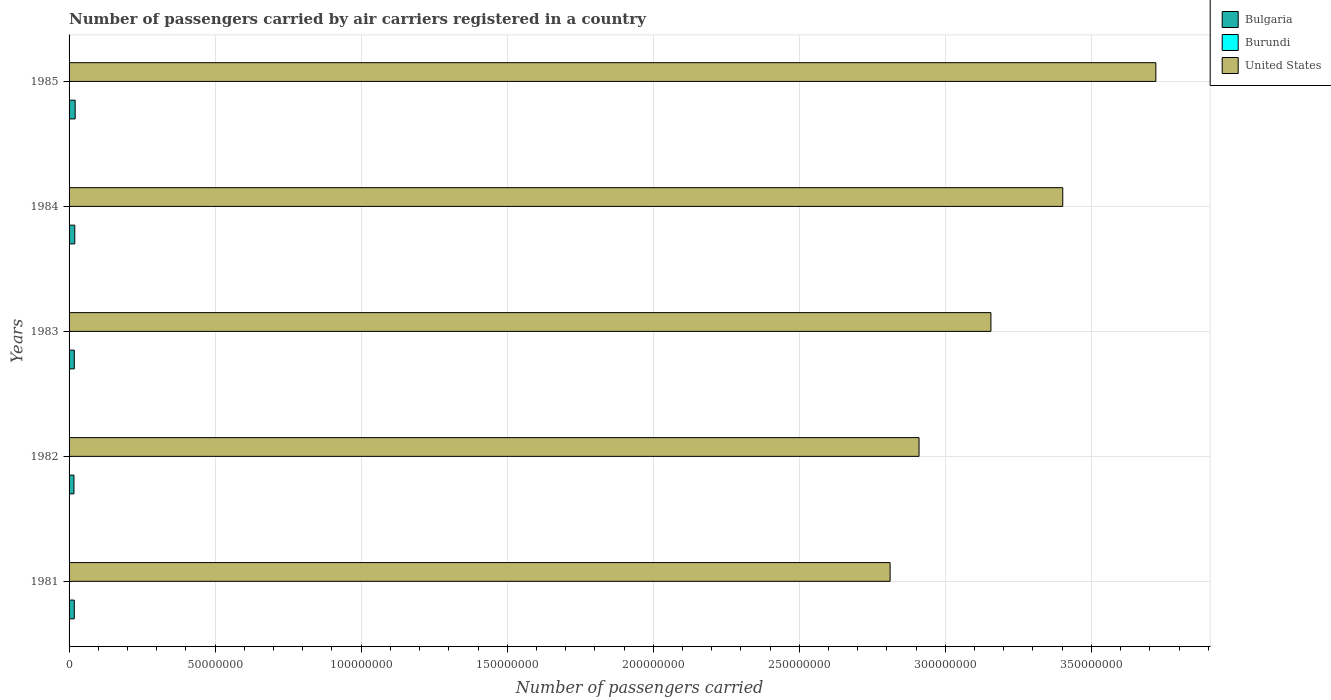How many different coloured bars are there?
Provide a short and direct response. 3. Are the number of bars on each tick of the Y-axis equal?
Provide a short and direct response. Yes. How many bars are there on the 1st tick from the top?
Your response must be concise. 3. What is the number of passengers carried by air carriers in United States in 1982?
Your response must be concise. 2.91e+08. Across all years, what is the maximum number of passengers carried by air carriers in United States?
Offer a very short reply. 3.72e+08. Across all years, what is the minimum number of passengers carried by air carriers in United States?
Keep it short and to the point. 2.81e+08. What is the total number of passengers carried by air carriers in Bulgaria in the graph?
Your response must be concise. 9.29e+06. What is the difference between the number of passengers carried by air carriers in Bulgaria in 1981 and that in 1984?
Keep it short and to the point. -1.63e+05. What is the difference between the number of passengers carried by air carriers in Burundi in 1985 and the number of passengers carried by air carriers in United States in 1983?
Provide a short and direct response. -3.16e+08. What is the average number of passengers carried by air carriers in Bulgaria per year?
Provide a succinct answer. 1.86e+06. In the year 1982, what is the difference between the number of passengers carried by air carriers in Burundi and number of passengers carried by air carriers in Bulgaria?
Keep it short and to the point. -1.67e+06. In how many years, is the number of passengers carried by air carriers in Burundi greater than 180000000 ?
Your response must be concise. 0. What is the ratio of the number of passengers carried by air carriers in Burundi in 1984 to that in 1985?
Keep it short and to the point. 1.02. Is the number of passengers carried by air carriers in Bulgaria in 1982 less than that in 1985?
Provide a succinct answer. Yes. What is the difference between the highest and the lowest number of passengers carried by air carriers in Burundi?
Make the answer very short. 3800. What does the 2nd bar from the top in 1983 represents?
Make the answer very short. Burundi. Are all the bars in the graph horizontal?
Give a very brief answer. Yes. Are the values on the major ticks of X-axis written in scientific E-notation?
Offer a terse response. No. Does the graph contain any zero values?
Make the answer very short. No. Does the graph contain grids?
Offer a terse response. Yes. What is the title of the graph?
Offer a terse response. Number of passengers carried by air carriers registered in a country. What is the label or title of the X-axis?
Offer a very short reply. Number of passengers carried. What is the Number of passengers carried of Bulgaria in 1981?
Your answer should be compact. 1.79e+06. What is the Number of passengers carried of United States in 1981?
Your response must be concise. 2.81e+08. What is the Number of passengers carried in Bulgaria in 1982?
Provide a succinct answer. 1.68e+06. What is the Number of passengers carried in Burundi in 1982?
Offer a terse response. 5500. What is the Number of passengers carried of United States in 1982?
Offer a very short reply. 2.91e+08. What is the Number of passengers carried of Bulgaria in 1983?
Your answer should be very brief. 1.79e+06. What is the Number of passengers carried in Burundi in 1983?
Ensure brevity in your answer.  6000. What is the Number of passengers carried of United States in 1983?
Offer a very short reply. 3.16e+08. What is the Number of passengers carried in Bulgaria in 1984?
Your answer should be very brief. 1.95e+06. What is the Number of passengers carried of Burundi in 1984?
Offer a very short reply. 8800. What is the Number of passengers carried of United States in 1984?
Your answer should be very brief. 3.40e+08. What is the Number of passengers carried of Bulgaria in 1985?
Give a very brief answer. 2.09e+06. What is the Number of passengers carried of Burundi in 1985?
Keep it short and to the point. 8600. What is the Number of passengers carried of United States in 1985?
Your response must be concise. 3.72e+08. Across all years, what is the maximum Number of passengers carried in Bulgaria?
Offer a very short reply. 2.09e+06. Across all years, what is the maximum Number of passengers carried of Burundi?
Your response must be concise. 8800. Across all years, what is the maximum Number of passengers carried in United States?
Offer a very short reply. 3.72e+08. Across all years, what is the minimum Number of passengers carried of Bulgaria?
Offer a very short reply. 1.68e+06. Across all years, what is the minimum Number of passengers carried of United States?
Your response must be concise. 2.81e+08. What is the total Number of passengers carried of Bulgaria in the graph?
Your response must be concise. 9.29e+06. What is the total Number of passengers carried of Burundi in the graph?
Keep it short and to the point. 3.39e+04. What is the total Number of passengers carried in United States in the graph?
Ensure brevity in your answer.  1.60e+09. What is the difference between the Number of passengers carried of Bulgaria in 1981 and that in 1982?
Provide a short and direct response. 1.12e+05. What is the difference between the Number of passengers carried in Burundi in 1981 and that in 1982?
Provide a short and direct response. -500. What is the difference between the Number of passengers carried in United States in 1981 and that in 1982?
Give a very brief answer. -9.91e+06. What is the difference between the Number of passengers carried of Bulgaria in 1981 and that in 1983?
Make the answer very short. -3000. What is the difference between the Number of passengers carried of Burundi in 1981 and that in 1983?
Offer a very short reply. -1000. What is the difference between the Number of passengers carried of United States in 1981 and that in 1983?
Offer a terse response. -3.45e+07. What is the difference between the Number of passengers carried in Bulgaria in 1981 and that in 1984?
Provide a short and direct response. -1.63e+05. What is the difference between the Number of passengers carried of Burundi in 1981 and that in 1984?
Provide a succinct answer. -3800. What is the difference between the Number of passengers carried in United States in 1981 and that in 1984?
Offer a terse response. -5.91e+07. What is the difference between the Number of passengers carried of Bulgaria in 1981 and that in 1985?
Provide a succinct answer. -3.03e+05. What is the difference between the Number of passengers carried of Burundi in 1981 and that in 1985?
Provide a succinct answer. -3600. What is the difference between the Number of passengers carried of United States in 1981 and that in 1985?
Provide a succinct answer. -9.10e+07. What is the difference between the Number of passengers carried of Bulgaria in 1982 and that in 1983?
Your answer should be compact. -1.15e+05. What is the difference between the Number of passengers carried in Burundi in 1982 and that in 1983?
Make the answer very short. -500. What is the difference between the Number of passengers carried of United States in 1982 and that in 1983?
Your answer should be compact. -2.46e+07. What is the difference between the Number of passengers carried in Bulgaria in 1982 and that in 1984?
Offer a very short reply. -2.75e+05. What is the difference between the Number of passengers carried of Burundi in 1982 and that in 1984?
Offer a very short reply. -3300. What is the difference between the Number of passengers carried of United States in 1982 and that in 1984?
Your answer should be compact. -4.92e+07. What is the difference between the Number of passengers carried in Bulgaria in 1982 and that in 1985?
Make the answer very short. -4.15e+05. What is the difference between the Number of passengers carried of Burundi in 1982 and that in 1985?
Ensure brevity in your answer.  -3100. What is the difference between the Number of passengers carried of United States in 1982 and that in 1985?
Ensure brevity in your answer.  -8.11e+07. What is the difference between the Number of passengers carried in Burundi in 1983 and that in 1984?
Give a very brief answer. -2800. What is the difference between the Number of passengers carried in United States in 1983 and that in 1984?
Make the answer very short. -2.46e+07. What is the difference between the Number of passengers carried of Bulgaria in 1983 and that in 1985?
Make the answer very short. -3.00e+05. What is the difference between the Number of passengers carried of Burundi in 1983 and that in 1985?
Provide a short and direct response. -2600. What is the difference between the Number of passengers carried in United States in 1983 and that in 1985?
Keep it short and to the point. -5.65e+07. What is the difference between the Number of passengers carried of Bulgaria in 1984 and that in 1985?
Offer a terse response. -1.40e+05. What is the difference between the Number of passengers carried in United States in 1984 and that in 1985?
Your answer should be very brief. -3.19e+07. What is the difference between the Number of passengers carried of Bulgaria in 1981 and the Number of passengers carried of Burundi in 1982?
Offer a terse response. 1.78e+06. What is the difference between the Number of passengers carried of Bulgaria in 1981 and the Number of passengers carried of United States in 1982?
Keep it short and to the point. -2.89e+08. What is the difference between the Number of passengers carried of Burundi in 1981 and the Number of passengers carried of United States in 1982?
Keep it short and to the point. -2.91e+08. What is the difference between the Number of passengers carried of Bulgaria in 1981 and the Number of passengers carried of Burundi in 1983?
Offer a very short reply. 1.78e+06. What is the difference between the Number of passengers carried in Bulgaria in 1981 and the Number of passengers carried in United States in 1983?
Provide a short and direct response. -3.14e+08. What is the difference between the Number of passengers carried in Burundi in 1981 and the Number of passengers carried in United States in 1983?
Provide a succinct answer. -3.16e+08. What is the difference between the Number of passengers carried in Bulgaria in 1981 and the Number of passengers carried in Burundi in 1984?
Your response must be concise. 1.78e+06. What is the difference between the Number of passengers carried in Bulgaria in 1981 and the Number of passengers carried in United States in 1984?
Give a very brief answer. -3.38e+08. What is the difference between the Number of passengers carried of Burundi in 1981 and the Number of passengers carried of United States in 1984?
Ensure brevity in your answer.  -3.40e+08. What is the difference between the Number of passengers carried of Bulgaria in 1981 and the Number of passengers carried of Burundi in 1985?
Provide a short and direct response. 1.78e+06. What is the difference between the Number of passengers carried of Bulgaria in 1981 and the Number of passengers carried of United States in 1985?
Make the answer very short. -3.70e+08. What is the difference between the Number of passengers carried of Burundi in 1981 and the Number of passengers carried of United States in 1985?
Keep it short and to the point. -3.72e+08. What is the difference between the Number of passengers carried of Bulgaria in 1982 and the Number of passengers carried of Burundi in 1983?
Provide a short and direct response. 1.67e+06. What is the difference between the Number of passengers carried in Bulgaria in 1982 and the Number of passengers carried in United States in 1983?
Provide a succinct answer. -3.14e+08. What is the difference between the Number of passengers carried of Burundi in 1982 and the Number of passengers carried of United States in 1983?
Offer a terse response. -3.16e+08. What is the difference between the Number of passengers carried of Bulgaria in 1982 and the Number of passengers carried of Burundi in 1984?
Provide a short and direct response. 1.67e+06. What is the difference between the Number of passengers carried in Bulgaria in 1982 and the Number of passengers carried in United States in 1984?
Keep it short and to the point. -3.39e+08. What is the difference between the Number of passengers carried of Burundi in 1982 and the Number of passengers carried of United States in 1984?
Offer a terse response. -3.40e+08. What is the difference between the Number of passengers carried in Bulgaria in 1982 and the Number of passengers carried in Burundi in 1985?
Provide a succinct answer. 1.67e+06. What is the difference between the Number of passengers carried of Bulgaria in 1982 and the Number of passengers carried of United States in 1985?
Keep it short and to the point. -3.70e+08. What is the difference between the Number of passengers carried of Burundi in 1982 and the Number of passengers carried of United States in 1985?
Offer a very short reply. -3.72e+08. What is the difference between the Number of passengers carried in Bulgaria in 1983 and the Number of passengers carried in Burundi in 1984?
Offer a terse response. 1.78e+06. What is the difference between the Number of passengers carried in Bulgaria in 1983 and the Number of passengers carried in United States in 1984?
Offer a very short reply. -3.38e+08. What is the difference between the Number of passengers carried of Burundi in 1983 and the Number of passengers carried of United States in 1984?
Give a very brief answer. -3.40e+08. What is the difference between the Number of passengers carried in Bulgaria in 1983 and the Number of passengers carried in Burundi in 1985?
Provide a short and direct response. 1.78e+06. What is the difference between the Number of passengers carried in Bulgaria in 1983 and the Number of passengers carried in United States in 1985?
Give a very brief answer. -3.70e+08. What is the difference between the Number of passengers carried of Burundi in 1983 and the Number of passengers carried of United States in 1985?
Your response must be concise. -3.72e+08. What is the difference between the Number of passengers carried of Bulgaria in 1984 and the Number of passengers carried of Burundi in 1985?
Offer a terse response. 1.94e+06. What is the difference between the Number of passengers carried in Bulgaria in 1984 and the Number of passengers carried in United States in 1985?
Give a very brief answer. -3.70e+08. What is the difference between the Number of passengers carried in Burundi in 1984 and the Number of passengers carried in United States in 1985?
Give a very brief answer. -3.72e+08. What is the average Number of passengers carried in Bulgaria per year?
Offer a terse response. 1.86e+06. What is the average Number of passengers carried of Burundi per year?
Give a very brief answer. 6780. What is the average Number of passengers carried in United States per year?
Offer a very short reply. 3.20e+08. In the year 1981, what is the difference between the Number of passengers carried of Bulgaria and Number of passengers carried of Burundi?
Offer a very short reply. 1.78e+06. In the year 1981, what is the difference between the Number of passengers carried in Bulgaria and Number of passengers carried in United States?
Make the answer very short. -2.79e+08. In the year 1981, what is the difference between the Number of passengers carried of Burundi and Number of passengers carried of United States?
Your response must be concise. -2.81e+08. In the year 1982, what is the difference between the Number of passengers carried in Bulgaria and Number of passengers carried in Burundi?
Your response must be concise. 1.67e+06. In the year 1982, what is the difference between the Number of passengers carried of Bulgaria and Number of passengers carried of United States?
Your answer should be very brief. -2.89e+08. In the year 1982, what is the difference between the Number of passengers carried in Burundi and Number of passengers carried in United States?
Offer a terse response. -2.91e+08. In the year 1983, what is the difference between the Number of passengers carried in Bulgaria and Number of passengers carried in Burundi?
Provide a short and direct response. 1.78e+06. In the year 1983, what is the difference between the Number of passengers carried of Bulgaria and Number of passengers carried of United States?
Your answer should be very brief. -3.14e+08. In the year 1983, what is the difference between the Number of passengers carried of Burundi and Number of passengers carried of United States?
Your answer should be compact. -3.16e+08. In the year 1984, what is the difference between the Number of passengers carried in Bulgaria and Number of passengers carried in Burundi?
Make the answer very short. 1.94e+06. In the year 1984, what is the difference between the Number of passengers carried of Bulgaria and Number of passengers carried of United States?
Offer a very short reply. -3.38e+08. In the year 1984, what is the difference between the Number of passengers carried of Burundi and Number of passengers carried of United States?
Ensure brevity in your answer.  -3.40e+08. In the year 1985, what is the difference between the Number of passengers carried of Bulgaria and Number of passengers carried of Burundi?
Your answer should be very brief. 2.08e+06. In the year 1985, what is the difference between the Number of passengers carried of Bulgaria and Number of passengers carried of United States?
Provide a short and direct response. -3.70e+08. In the year 1985, what is the difference between the Number of passengers carried in Burundi and Number of passengers carried in United States?
Provide a succinct answer. -3.72e+08. What is the ratio of the Number of passengers carried of Bulgaria in 1981 to that in 1982?
Provide a succinct answer. 1.07. What is the ratio of the Number of passengers carried of Burundi in 1981 to that in 1982?
Offer a very short reply. 0.91. What is the ratio of the Number of passengers carried of United States in 1981 to that in 1982?
Give a very brief answer. 0.97. What is the ratio of the Number of passengers carried in Bulgaria in 1981 to that in 1983?
Give a very brief answer. 1. What is the ratio of the Number of passengers carried in Burundi in 1981 to that in 1983?
Your response must be concise. 0.83. What is the ratio of the Number of passengers carried in United States in 1981 to that in 1983?
Provide a short and direct response. 0.89. What is the ratio of the Number of passengers carried of Bulgaria in 1981 to that in 1984?
Your answer should be very brief. 0.92. What is the ratio of the Number of passengers carried of Burundi in 1981 to that in 1984?
Your response must be concise. 0.57. What is the ratio of the Number of passengers carried of United States in 1981 to that in 1984?
Offer a terse response. 0.83. What is the ratio of the Number of passengers carried in Bulgaria in 1981 to that in 1985?
Keep it short and to the point. 0.85. What is the ratio of the Number of passengers carried of Burundi in 1981 to that in 1985?
Give a very brief answer. 0.58. What is the ratio of the Number of passengers carried of United States in 1981 to that in 1985?
Ensure brevity in your answer.  0.76. What is the ratio of the Number of passengers carried of Bulgaria in 1982 to that in 1983?
Provide a short and direct response. 0.94. What is the ratio of the Number of passengers carried of Burundi in 1982 to that in 1983?
Ensure brevity in your answer.  0.92. What is the ratio of the Number of passengers carried in United States in 1982 to that in 1983?
Offer a very short reply. 0.92. What is the ratio of the Number of passengers carried of Bulgaria in 1982 to that in 1984?
Your answer should be very brief. 0.86. What is the ratio of the Number of passengers carried of Burundi in 1982 to that in 1984?
Give a very brief answer. 0.62. What is the ratio of the Number of passengers carried of United States in 1982 to that in 1984?
Give a very brief answer. 0.86. What is the ratio of the Number of passengers carried of Bulgaria in 1982 to that in 1985?
Give a very brief answer. 0.8. What is the ratio of the Number of passengers carried in Burundi in 1982 to that in 1985?
Offer a very short reply. 0.64. What is the ratio of the Number of passengers carried of United States in 1982 to that in 1985?
Your answer should be very brief. 0.78. What is the ratio of the Number of passengers carried of Bulgaria in 1983 to that in 1984?
Keep it short and to the point. 0.92. What is the ratio of the Number of passengers carried of Burundi in 1983 to that in 1984?
Ensure brevity in your answer.  0.68. What is the ratio of the Number of passengers carried in United States in 1983 to that in 1984?
Make the answer very short. 0.93. What is the ratio of the Number of passengers carried in Bulgaria in 1983 to that in 1985?
Provide a succinct answer. 0.86. What is the ratio of the Number of passengers carried of Burundi in 1983 to that in 1985?
Offer a very short reply. 0.7. What is the ratio of the Number of passengers carried in United States in 1983 to that in 1985?
Your response must be concise. 0.85. What is the ratio of the Number of passengers carried in Bulgaria in 1984 to that in 1985?
Provide a succinct answer. 0.93. What is the ratio of the Number of passengers carried in Burundi in 1984 to that in 1985?
Your answer should be compact. 1.02. What is the ratio of the Number of passengers carried of United States in 1984 to that in 1985?
Your answer should be compact. 0.91. What is the difference between the highest and the second highest Number of passengers carried of United States?
Provide a short and direct response. 3.19e+07. What is the difference between the highest and the lowest Number of passengers carried in Bulgaria?
Ensure brevity in your answer.  4.15e+05. What is the difference between the highest and the lowest Number of passengers carried of Burundi?
Ensure brevity in your answer.  3800. What is the difference between the highest and the lowest Number of passengers carried of United States?
Offer a very short reply. 9.10e+07. 